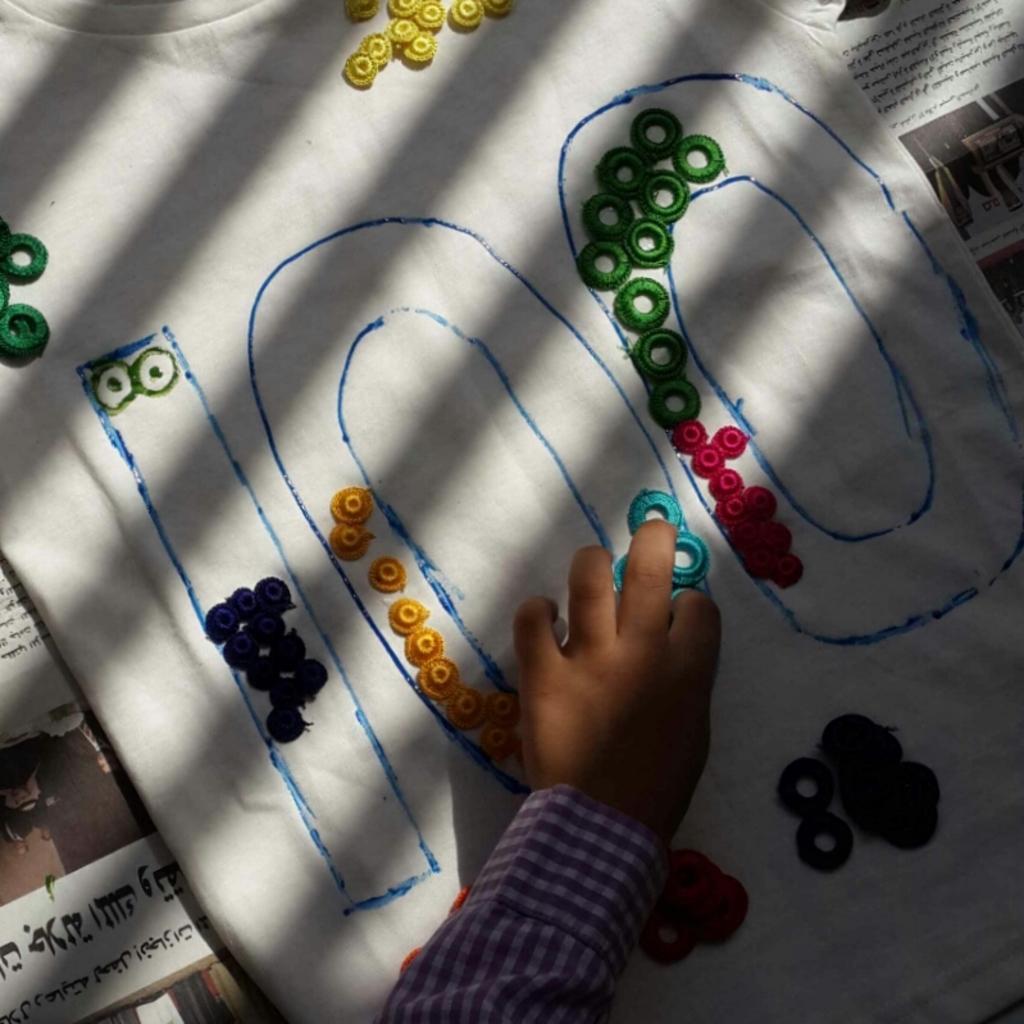Could you give a brief overview of what you see in this image? There are some objects and a hand on the cloth and newspapers in the image. 